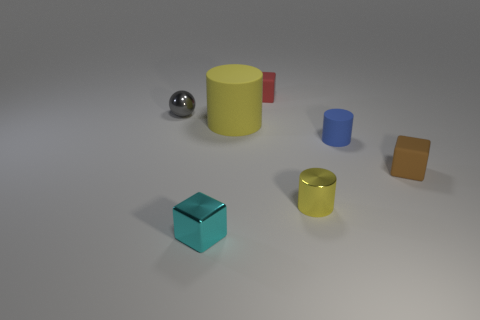What size is the yellow matte object that is the same shape as the tiny blue thing?
Provide a short and direct response. Large. There is a yellow cylinder that is made of the same material as the red block; what is its size?
Provide a short and direct response. Large. What number of tiny cylinders are the same color as the large matte object?
Offer a terse response. 1. There is a cylinder behind the tiny blue object; how big is it?
Give a very brief answer. Large. There is another cylinder that is the same color as the shiny cylinder; what is its size?
Make the answer very short. Large. Does the brown rubber object have the same size as the yellow cylinder that is left of the red thing?
Your answer should be very brief. No. What number of things are either brown matte objects or tiny metal things?
Provide a short and direct response. 4. How many other things are there of the same size as the metal cylinder?
Ensure brevity in your answer.  5. There is a big cylinder; is its color the same as the tiny shiny thing on the right side of the large matte thing?
Your answer should be compact. Yes. What number of blocks are either red matte things or large yellow rubber objects?
Keep it short and to the point. 1. 